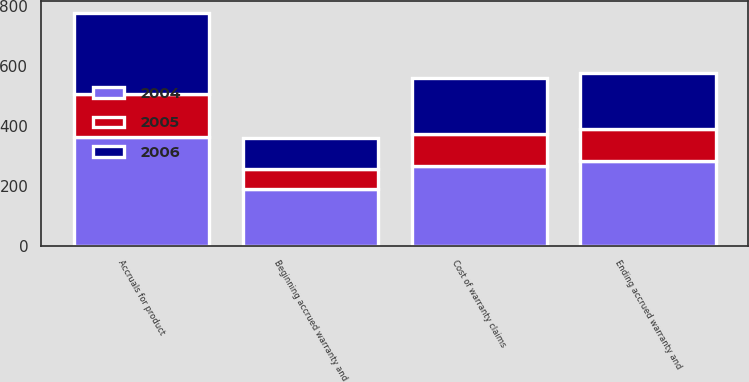<chart> <loc_0><loc_0><loc_500><loc_500><stacked_bar_chart><ecel><fcel>Beginning accrued warranty and<fcel>Cost of warranty claims<fcel>Accruals for product<fcel>Ending accrued warranty and<nl><fcel>2004<fcel>188<fcel>267<fcel>363<fcel>284<nl><fcel>2006<fcel>105<fcel>188<fcel>271<fcel>188<nl><fcel>2005<fcel>67<fcel>105<fcel>143<fcel>105<nl></chart> 